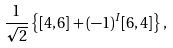Convert formula to latex. <formula><loc_0><loc_0><loc_500><loc_500>\frac { 1 } { \sqrt { 2 } } \left \{ [ 4 , 6 ] + ( - 1 ) ^ { I } [ 6 , 4 ] \right \} ,</formula> 